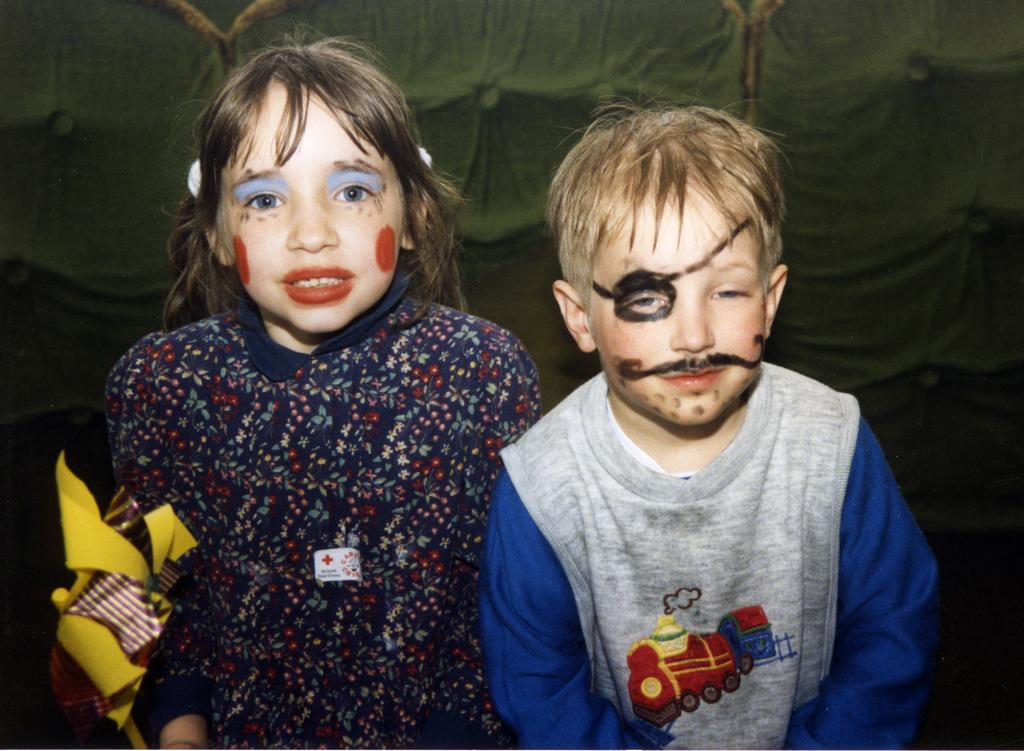How many people are present in the image? There are two persons standing in the image. What can be seen at the back of the image? There is a curtain at the back of the image. What type of substance is being used to clean the sweater in the image? There is no sweater or substance present in the image. What time of day is it in the image, considering the afternoon? The time of day cannot be determined from the image, as there are no clues or indications of the time. 